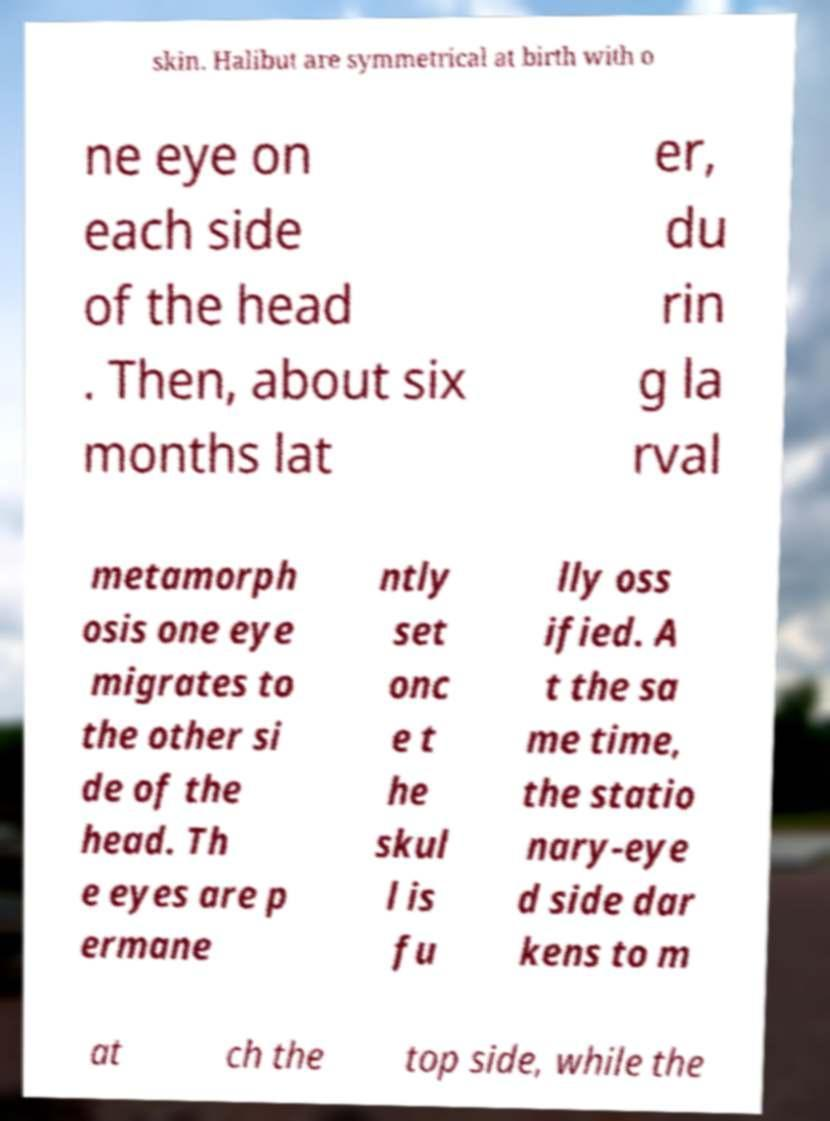I need the written content from this picture converted into text. Can you do that? skin. Halibut are symmetrical at birth with o ne eye on each side of the head . Then, about six months lat er, du rin g la rval metamorph osis one eye migrates to the other si de of the head. Th e eyes are p ermane ntly set onc e t he skul l is fu lly oss ified. A t the sa me time, the statio nary-eye d side dar kens to m at ch the top side, while the 